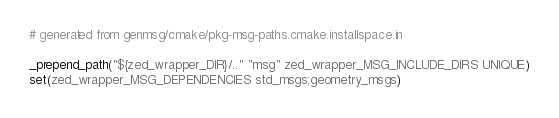Convert code to text. <code><loc_0><loc_0><loc_500><loc_500><_CMake_># generated from genmsg/cmake/pkg-msg-paths.cmake.installspace.in

_prepend_path("${zed_wrapper_DIR}/.." "msg" zed_wrapper_MSG_INCLUDE_DIRS UNIQUE)
set(zed_wrapper_MSG_DEPENDENCIES std_msgs;geometry_msgs)
</code> 